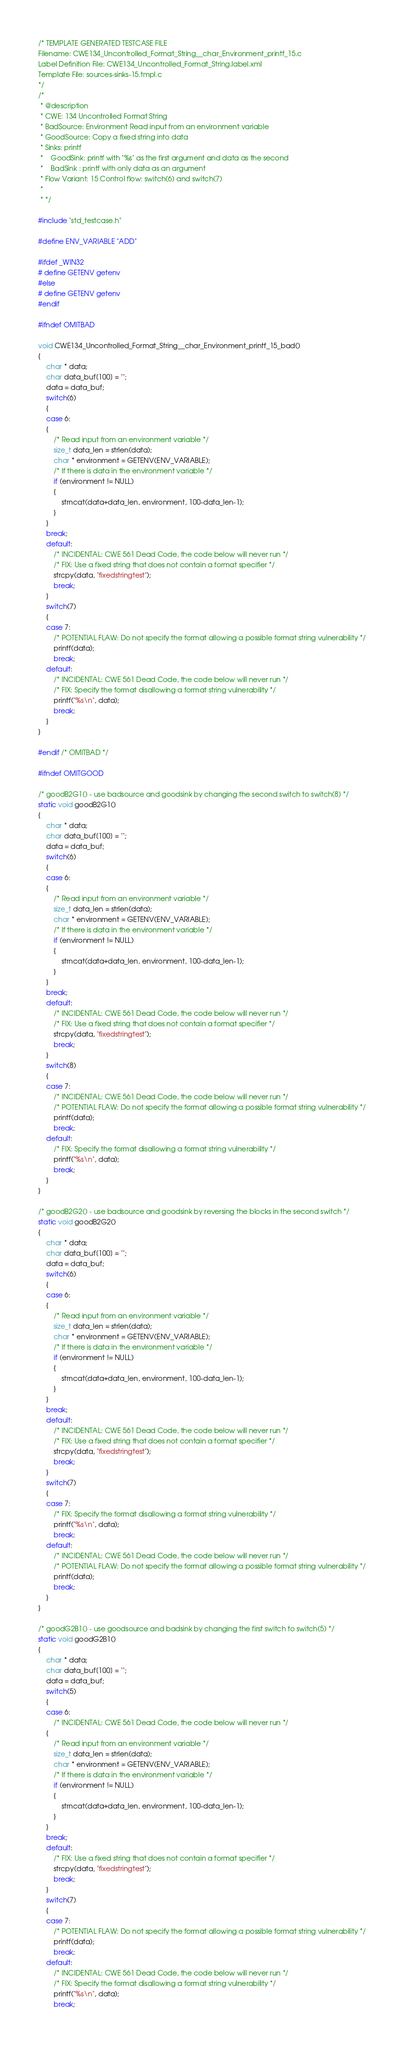<code> <loc_0><loc_0><loc_500><loc_500><_C_>/* TEMPLATE GENERATED TESTCASE FILE
Filename: CWE134_Uncontrolled_Format_String__char_Environment_printf_15.c
Label Definition File: CWE134_Uncontrolled_Format_String.label.xml
Template File: sources-sinks-15.tmpl.c
*/
/*
 * @description
 * CWE: 134 Uncontrolled Format String
 * BadSource: Environment Read input from an environment variable
 * GoodSource: Copy a fixed string into data
 * Sinks: printf
 *    GoodSink: printf with "%s" as the first argument and data as the second
 *    BadSink : printf with only data as an argument
 * Flow Variant: 15 Control flow: switch(6) and switch(7)
 *
 * */

#include "std_testcase.h"

#define ENV_VARIABLE "ADD"

#ifdef _WIN32
# define GETENV getenv
#else
# define GETENV getenv
#endif

#ifndef OMITBAD

void CWE134_Uncontrolled_Format_String__char_Environment_printf_15_bad()
{
    char * data;
    char data_buf[100] = "";
    data = data_buf;
    switch(6)
    {
    case 6:
    {
        /* Read input from an environment variable */
        size_t data_len = strlen(data);
        char * environment = GETENV(ENV_VARIABLE);
        /* If there is data in the environment variable */
        if (environment != NULL)
        {
            strncat(data+data_len, environment, 100-data_len-1);
        }
    }
    break;
    default:
        /* INCIDENTAL: CWE 561 Dead Code, the code below will never run */
        /* FIX: Use a fixed string that does not contain a format specifier */
        strcpy(data, "fixedstringtest");
        break;
    }
    switch(7)
    {
    case 7:
        /* POTENTIAL FLAW: Do not specify the format allowing a possible format string vulnerability */
        printf(data);
        break;
    default:
        /* INCIDENTAL: CWE 561 Dead Code, the code below will never run */
        /* FIX: Specify the format disallowing a format string vulnerability */
        printf("%s\n", data);
        break;
    }
}

#endif /* OMITBAD */

#ifndef OMITGOOD

/* goodB2G1() - use badsource and goodsink by changing the second switch to switch(8) */
static void goodB2G1()
{
    char * data;
    char data_buf[100] = "";
    data = data_buf;
    switch(6)
    {
    case 6:
    {
        /* Read input from an environment variable */
        size_t data_len = strlen(data);
        char * environment = GETENV(ENV_VARIABLE);
        /* If there is data in the environment variable */
        if (environment != NULL)
        {
            strncat(data+data_len, environment, 100-data_len-1);
        }
    }
    break;
    default:
        /* INCIDENTAL: CWE 561 Dead Code, the code below will never run */
        /* FIX: Use a fixed string that does not contain a format specifier */
        strcpy(data, "fixedstringtest");
        break;
    }
    switch(8)
    {
    case 7:
        /* INCIDENTAL: CWE 561 Dead Code, the code below will never run */
        /* POTENTIAL FLAW: Do not specify the format allowing a possible format string vulnerability */
        printf(data);
        break;
    default:
        /* FIX: Specify the format disallowing a format string vulnerability */
        printf("%s\n", data);
        break;
    }
}

/* goodB2G2() - use badsource and goodsink by reversing the blocks in the second switch */
static void goodB2G2()
{
    char * data;
    char data_buf[100] = "";
    data = data_buf;
    switch(6)
    {
    case 6:
    {
        /* Read input from an environment variable */
        size_t data_len = strlen(data);
        char * environment = GETENV(ENV_VARIABLE);
        /* If there is data in the environment variable */
        if (environment != NULL)
        {
            strncat(data+data_len, environment, 100-data_len-1);
        }
    }
    break;
    default:
        /* INCIDENTAL: CWE 561 Dead Code, the code below will never run */
        /* FIX: Use a fixed string that does not contain a format specifier */
        strcpy(data, "fixedstringtest");
        break;
    }
    switch(7)
    {
    case 7:
        /* FIX: Specify the format disallowing a format string vulnerability */
        printf("%s\n", data);
        break;
    default:
        /* INCIDENTAL: CWE 561 Dead Code, the code below will never run */
        /* POTENTIAL FLAW: Do not specify the format allowing a possible format string vulnerability */
        printf(data);
        break;
    }
}

/* goodG2B1() - use goodsource and badsink by changing the first switch to switch(5) */
static void goodG2B1()
{
    char * data;
    char data_buf[100] = "";
    data = data_buf;
    switch(5)
    {
    case 6:
        /* INCIDENTAL: CWE 561 Dead Code, the code below will never run */
    {
        /* Read input from an environment variable */
        size_t data_len = strlen(data);
        char * environment = GETENV(ENV_VARIABLE);
        /* If there is data in the environment variable */
        if (environment != NULL)
        {
            strncat(data+data_len, environment, 100-data_len-1);
        }
    }
    break;
    default:
        /* FIX: Use a fixed string that does not contain a format specifier */
        strcpy(data, "fixedstringtest");
        break;
    }
    switch(7)
    {
    case 7:
        /* POTENTIAL FLAW: Do not specify the format allowing a possible format string vulnerability */
        printf(data);
        break;
    default:
        /* INCIDENTAL: CWE 561 Dead Code, the code below will never run */
        /* FIX: Specify the format disallowing a format string vulnerability */
        printf("%s\n", data);
        break;</code> 